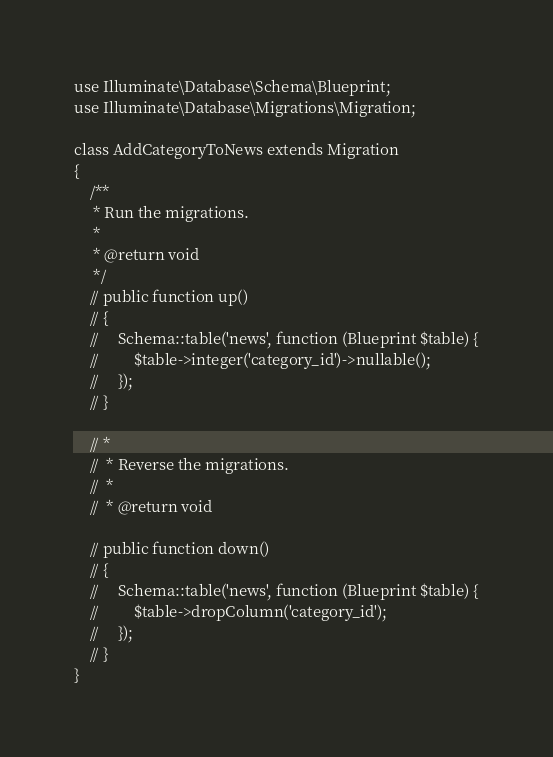<code> <loc_0><loc_0><loc_500><loc_500><_PHP_>use Illuminate\Database\Schema\Blueprint;
use Illuminate\Database\Migrations\Migration;

class AddCategoryToNews extends Migration
{
    /**
     * Run the migrations.
     *
     * @return void
     */
    // public function up()
    // {
    //     Schema::table('news', function (Blueprint $table) {
    //         $table->integer('category_id')->nullable();
    //     });
    // }

    // *
    //  * Reverse the migrations.
    //  *
    //  * @return void
     
    // public function down()
    // {
    //     Schema::table('news', function (Blueprint $table) {
    //         $table->dropColumn('category_id');
    //     });
    // }
}
</code> 